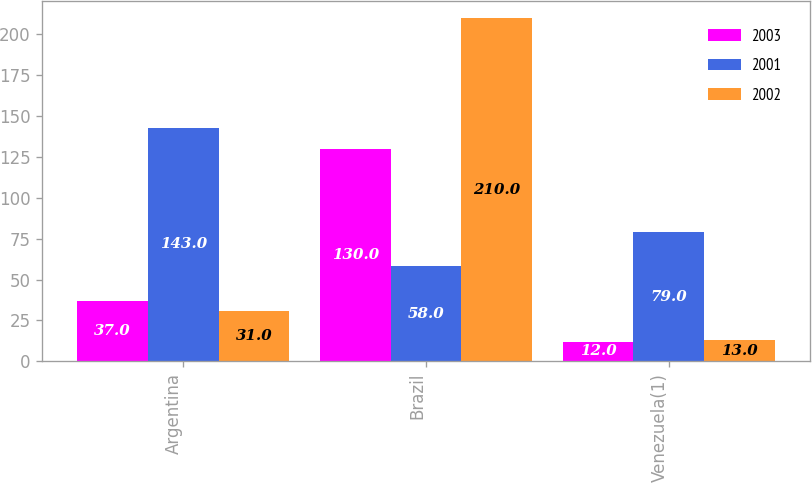Convert chart to OTSL. <chart><loc_0><loc_0><loc_500><loc_500><stacked_bar_chart><ecel><fcel>Argentina<fcel>Brazil<fcel>Venezuela(1)<nl><fcel>2003<fcel>37<fcel>130<fcel>12<nl><fcel>2001<fcel>143<fcel>58<fcel>79<nl><fcel>2002<fcel>31<fcel>210<fcel>13<nl></chart> 